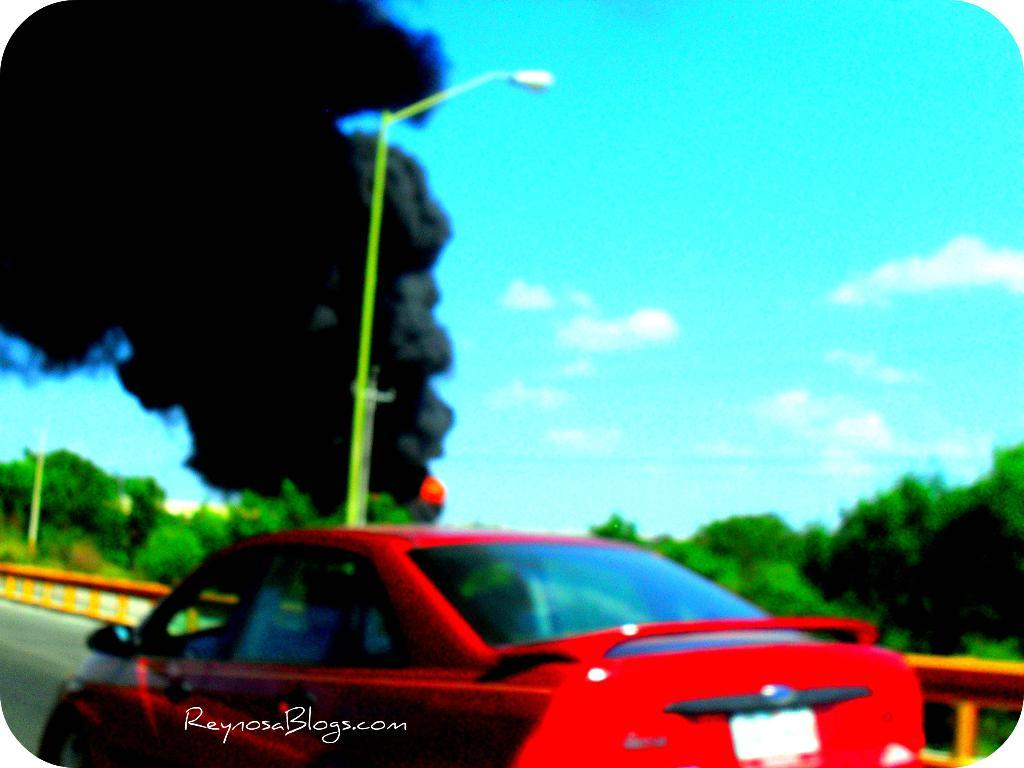What is the main subject of the image? The main subject of the image is a car. What is the car doing in the image? The car is moving on the road in the image. What can be seen in the background around the car? There are trees around the car in the image. What type of wrench is being used to paint the car's account in the image? There is no wrench, paint, or account present in the image; it only features a car moving on the road with trees in the background. 